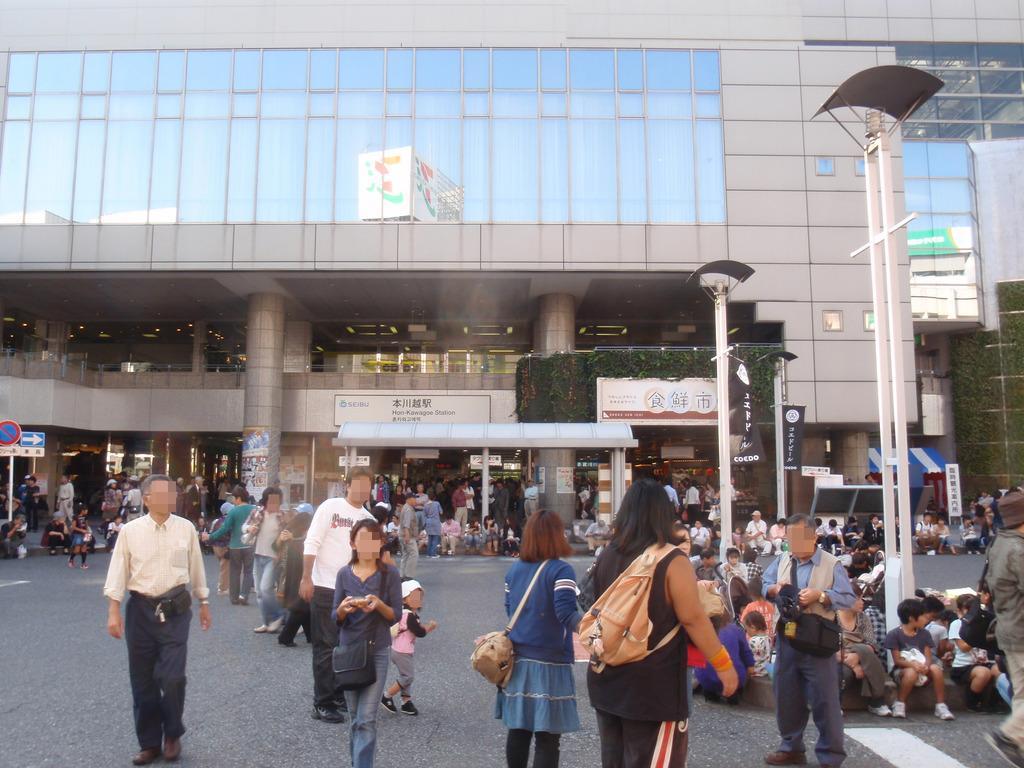Describe this image in one or two sentences. In this picture there is a building in the center of the image and there are people at the bottom side of the image, it seems to be the road side view. 